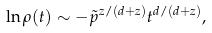Convert formula to latex. <formula><loc_0><loc_0><loc_500><loc_500>\ln \rho ( t ) \sim - \tilde { p } ^ { z / ( d + z ) } t ^ { d / ( d + z ) } ,</formula> 